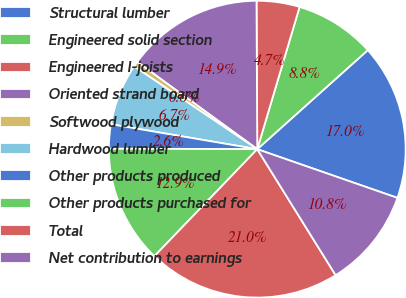Convert chart to OTSL. <chart><loc_0><loc_0><loc_500><loc_500><pie_chart><fcel>Structural lumber<fcel>Engineered solid section<fcel>Engineered I-joists<fcel>Oriented strand board<fcel>Softwood plywood<fcel>Hardwood lumber<fcel>Other products produced<fcel>Other products purchased for<fcel>Total<fcel>Net contribution to earnings<nl><fcel>16.95%<fcel>8.77%<fcel>4.68%<fcel>14.91%<fcel>0.59%<fcel>6.73%<fcel>2.64%<fcel>12.86%<fcel>21.04%<fcel>10.82%<nl></chart> 